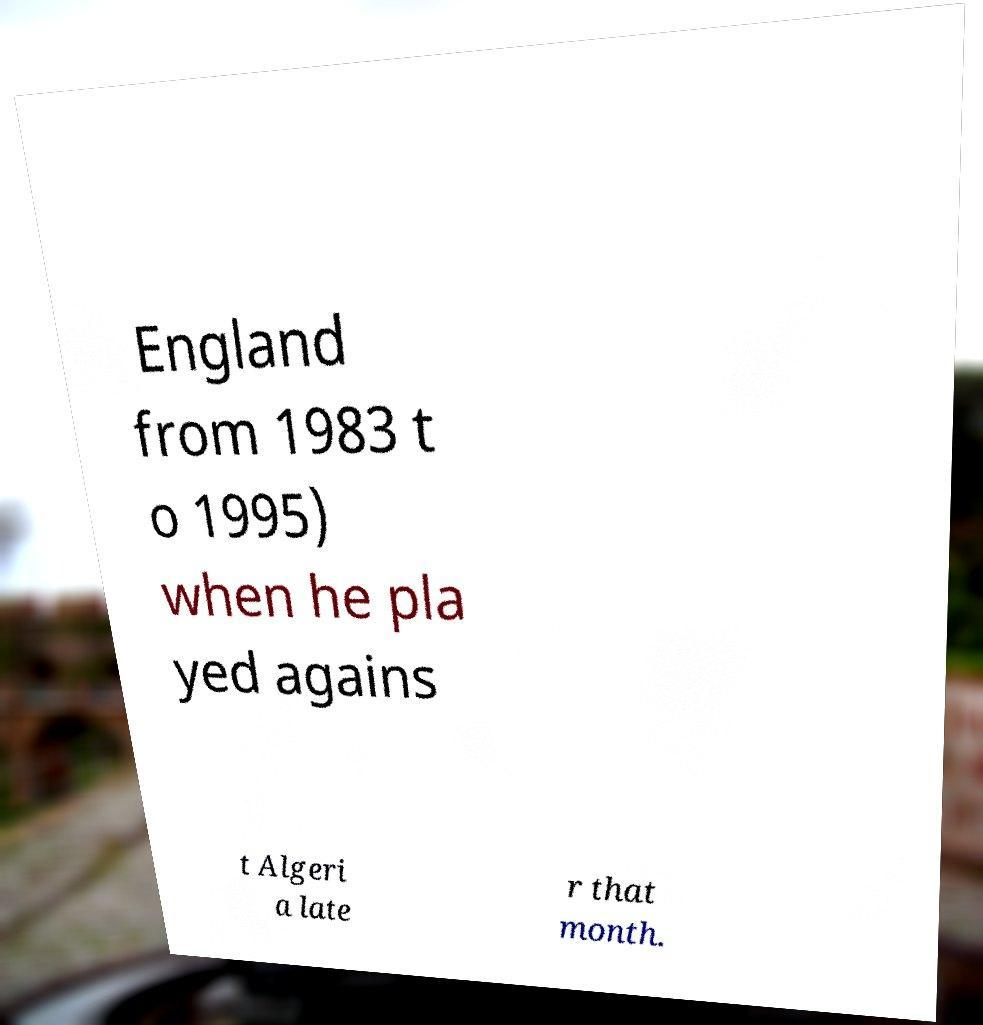Please identify and transcribe the text found in this image. England from 1983 t o 1995) when he pla yed agains t Algeri a late r that month. 